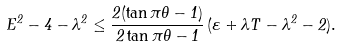Convert formula to latex. <formula><loc_0><loc_0><loc_500><loc_500>E ^ { 2 } - 4 - \lambda ^ { 2 } \leq \frac { 2 ( \tan \pi \theta - 1 ) } { 2 \tan \pi \theta - 1 } \, ( \varepsilon + \lambda T - \lambda ^ { 2 } - 2 ) .</formula> 